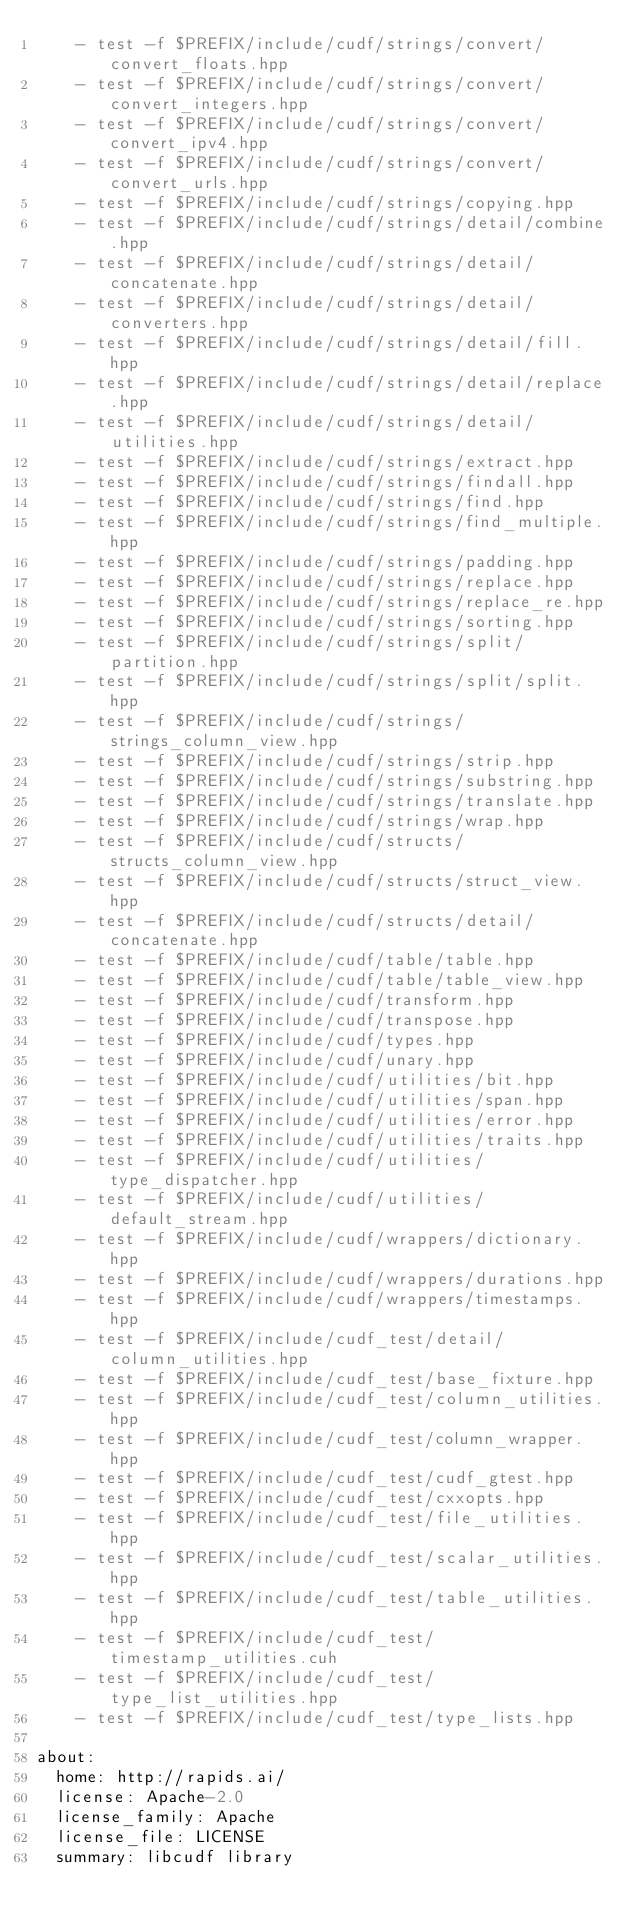<code> <loc_0><loc_0><loc_500><loc_500><_YAML_>    - test -f $PREFIX/include/cudf/strings/convert/convert_floats.hpp
    - test -f $PREFIX/include/cudf/strings/convert/convert_integers.hpp
    - test -f $PREFIX/include/cudf/strings/convert/convert_ipv4.hpp
    - test -f $PREFIX/include/cudf/strings/convert/convert_urls.hpp
    - test -f $PREFIX/include/cudf/strings/copying.hpp
    - test -f $PREFIX/include/cudf/strings/detail/combine.hpp
    - test -f $PREFIX/include/cudf/strings/detail/concatenate.hpp
    - test -f $PREFIX/include/cudf/strings/detail/converters.hpp
    - test -f $PREFIX/include/cudf/strings/detail/fill.hpp
    - test -f $PREFIX/include/cudf/strings/detail/replace.hpp
    - test -f $PREFIX/include/cudf/strings/detail/utilities.hpp
    - test -f $PREFIX/include/cudf/strings/extract.hpp
    - test -f $PREFIX/include/cudf/strings/findall.hpp
    - test -f $PREFIX/include/cudf/strings/find.hpp
    - test -f $PREFIX/include/cudf/strings/find_multiple.hpp
    - test -f $PREFIX/include/cudf/strings/padding.hpp
    - test -f $PREFIX/include/cudf/strings/replace.hpp
    - test -f $PREFIX/include/cudf/strings/replace_re.hpp
    - test -f $PREFIX/include/cudf/strings/sorting.hpp
    - test -f $PREFIX/include/cudf/strings/split/partition.hpp
    - test -f $PREFIX/include/cudf/strings/split/split.hpp
    - test -f $PREFIX/include/cudf/strings/strings_column_view.hpp
    - test -f $PREFIX/include/cudf/strings/strip.hpp
    - test -f $PREFIX/include/cudf/strings/substring.hpp
    - test -f $PREFIX/include/cudf/strings/translate.hpp
    - test -f $PREFIX/include/cudf/strings/wrap.hpp
    - test -f $PREFIX/include/cudf/structs/structs_column_view.hpp
    - test -f $PREFIX/include/cudf/structs/struct_view.hpp
    - test -f $PREFIX/include/cudf/structs/detail/concatenate.hpp
    - test -f $PREFIX/include/cudf/table/table.hpp
    - test -f $PREFIX/include/cudf/table/table_view.hpp
    - test -f $PREFIX/include/cudf/transform.hpp
    - test -f $PREFIX/include/cudf/transpose.hpp
    - test -f $PREFIX/include/cudf/types.hpp
    - test -f $PREFIX/include/cudf/unary.hpp
    - test -f $PREFIX/include/cudf/utilities/bit.hpp
    - test -f $PREFIX/include/cudf/utilities/span.hpp
    - test -f $PREFIX/include/cudf/utilities/error.hpp
    - test -f $PREFIX/include/cudf/utilities/traits.hpp
    - test -f $PREFIX/include/cudf/utilities/type_dispatcher.hpp
    - test -f $PREFIX/include/cudf/utilities/default_stream.hpp
    - test -f $PREFIX/include/cudf/wrappers/dictionary.hpp
    - test -f $PREFIX/include/cudf/wrappers/durations.hpp
    - test -f $PREFIX/include/cudf/wrappers/timestamps.hpp
    - test -f $PREFIX/include/cudf_test/detail/column_utilities.hpp
    - test -f $PREFIX/include/cudf_test/base_fixture.hpp
    - test -f $PREFIX/include/cudf_test/column_utilities.hpp
    - test -f $PREFIX/include/cudf_test/column_wrapper.hpp
    - test -f $PREFIX/include/cudf_test/cudf_gtest.hpp
    - test -f $PREFIX/include/cudf_test/cxxopts.hpp
    - test -f $PREFIX/include/cudf_test/file_utilities.hpp
    - test -f $PREFIX/include/cudf_test/scalar_utilities.hpp
    - test -f $PREFIX/include/cudf_test/table_utilities.hpp
    - test -f $PREFIX/include/cudf_test/timestamp_utilities.cuh
    - test -f $PREFIX/include/cudf_test/type_list_utilities.hpp
    - test -f $PREFIX/include/cudf_test/type_lists.hpp

about:
  home: http://rapids.ai/
  license: Apache-2.0
  license_family: Apache
  license_file: LICENSE
  summary: libcudf library
</code> 